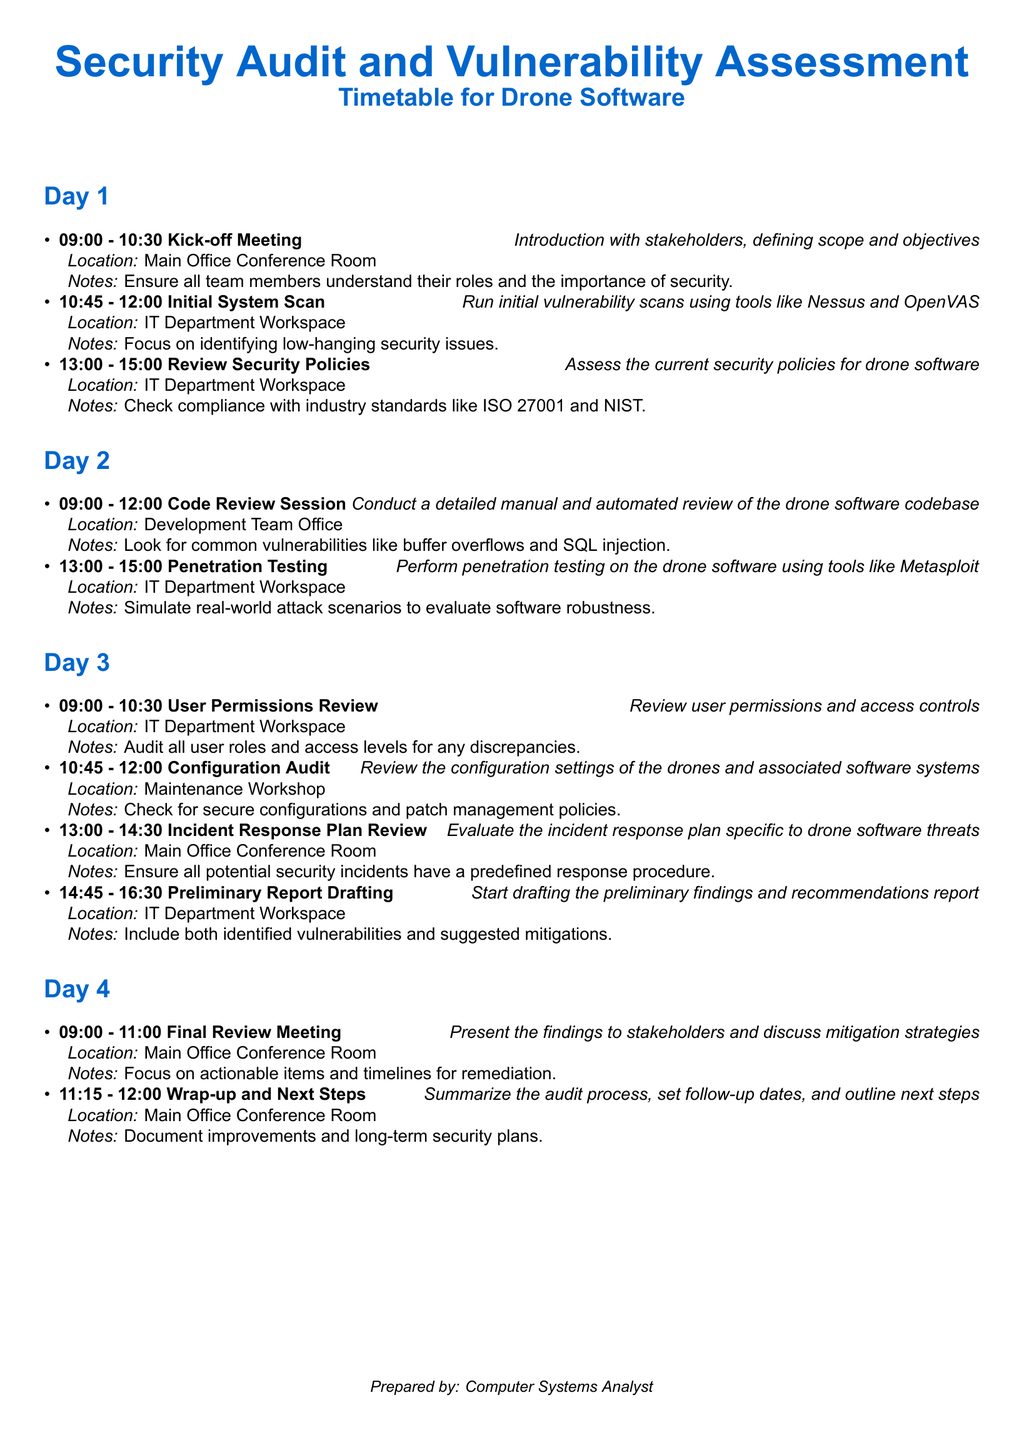What time does the Kick-off Meeting start? The Kick-off Meeting is scheduled for 09:00 on Day 1.
Answer: 09:00 What is the location for the Code Review Session? The Code Review Session takes place in the Development Team Office.
Answer: Development Team Office How long is the Incident Response Plan Review? The Incident Response Plan Review is scheduled for 1 hour and 30 minutes from 13:00 to 14:30.
Answer: 1 hour and 30 minutes What will be evaluated during the Configuration Audit? The Configuration Audit involves reviewing the configuration settings of the drones and associated software systems.
Answer: Configuration settings of the drones and associated software systems How many events are scheduled for Day 2? There are two events planned for Day 2: Code Review Session and Penetration Testing.
Answer: 2 What is the primary focus of the Final Review Meeting? The Final Review Meeting aims to present the findings to stakeholders and discuss mitigation strategies.
Answer: Present findings to stakeholders and discuss mitigation strategies What industry standards are referenced for security policy review? The event notes suggest checking compliance with ISO 27001 and NIST standards.
Answer: ISO 27001 and NIST At what time does the Wrap-up and Next Steps meeting end? The Wrap-up and Next Steps meeting is scheduled to end at 12:00 on Day 4.
Answer: 12:00 